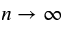Convert formula to latex. <formula><loc_0><loc_0><loc_500><loc_500>n \to \infty</formula> 